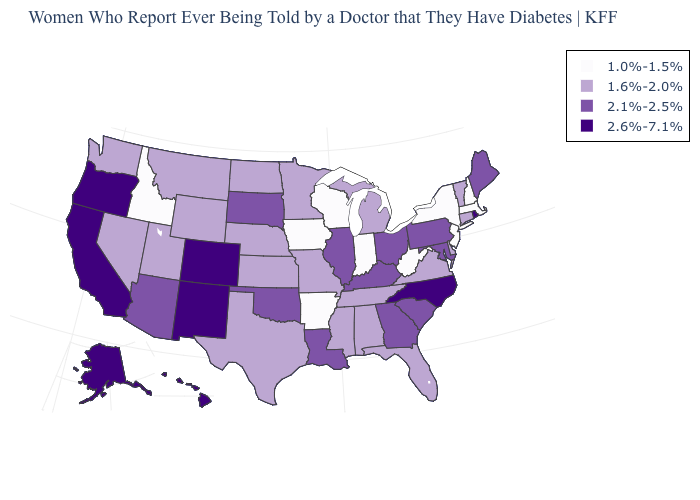Name the states that have a value in the range 1.6%-2.0%?
Keep it brief. Alabama, Connecticut, Delaware, Florida, Kansas, Michigan, Minnesota, Mississippi, Missouri, Montana, Nebraska, Nevada, North Dakota, Tennessee, Texas, Utah, Vermont, Virginia, Washington, Wyoming. Does the first symbol in the legend represent the smallest category?
Concise answer only. Yes. How many symbols are there in the legend?
Be succinct. 4. Name the states that have a value in the range 1.6%-2.0%?
Keep it brief. Alabama, Connecticut, Delaware, Florida, Kansas, Michigan, Minnesota, Mississippi, Missouri, Montana, Nebraska, Nevada, North Dakota, Tennessee, Texas, Utah, Vermont, Virginia, Washington, Wyoming. Which states have the lowest value in the West?
Be succinct. Idaho. Name the states that have a value in the range 1.6%-2.0%?
Be succinct. Alabama, Connecticut, Delaware, Florida, Kansas, Michigan, Minnesota, Mississippi, Missouri, Montana, Nebraska, Nevada, North Dakota, Tennessee, Texas, Utah, Vermont, Virginia, Washington, Wyoming. What is the value of Alaska?
Concise answer only. 2.6%-7.1%. Among the states that border Ohio , does Pennsylvania have the lowest value?
Give a very brief answer. No. What is the highest value in the South ?
Give a very brief answer. 2.6%-7.1%. What is the lowest value in the USA?
Short answer required. 1.0%-1.5%. Name the states that have a value in the range 1.6%-2.0%?
Be succinct. Alabama, Connecticut, Delaware, Florida, Kansas, Michigan, Minnesota, Mississippi, Missouri, Montana, Nebraska, Nevada, North Dakota, Tennessee, Texas, Utah, Vermont, Virginia, Washington, Wyoming. Which states have the lowest value in the West?
Short answer required. Idaho. Does California have the highest value in the USA?
Write a very short answer. Yes. Name the states that have a value in the range 2.6%-7.1%?
Give a very brief answer. Alaska, California, Colorado, Hawaii, New Mexico, North Carolina, Oregon, Rhode Island. 